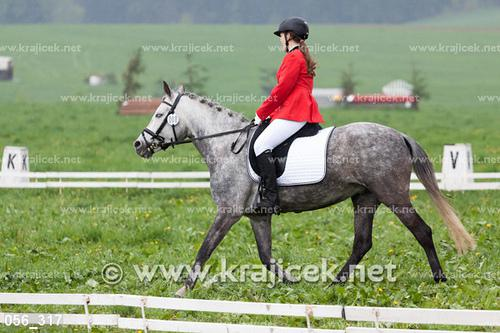Question: when was this picture taken?
Choices:
A. Daytime.
B. During a baptism.
C. During a party.
D. At night.
Answer with the letter. Answer: A Question: what color is the grass?
Choices:
A. Brown.
B. Yellow.
C. Black.
D. Green.
Answer with the letter. Answer: D Question: what color is the horse?
Choices:
A. Brown.
B. Grey.
C. White.
D. Black.
Answer with the letter. Answer: B Question: what color is the saddle blanket?
Choices:
A. Yellow.
B. White.
C. Black.
D. Green.
Answer with the letter. Answer: B 